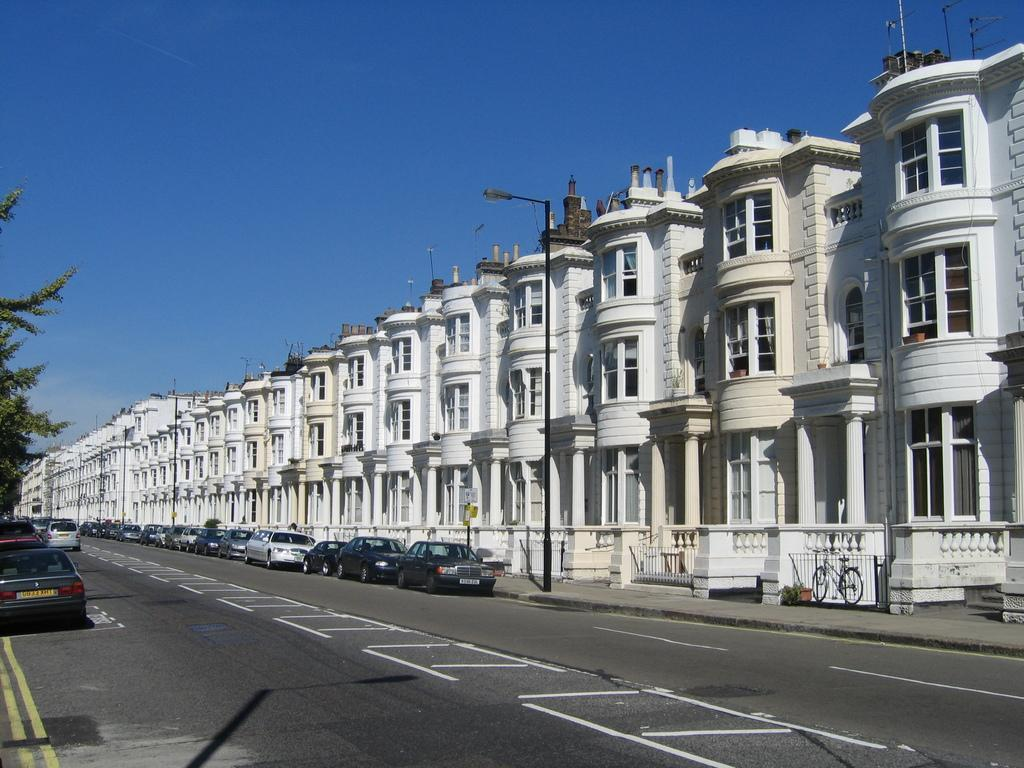What type of structures can be seen in the image? There are buildings in the image. What type of lighting is present in the image? There is a street lamp in the image. What architectural features can be seen on the buildings? There are windows visible in the image. What type of transportation is present in the image? There are vehicles in the image. What type of vegetation is present in the image? There is a tree in the image. What is visible in the background of the image? The sky is visible in the image. What type of glue is being used to hold the paper together in the image? There is no paper or glue present in the image; it features buildings, a street lamp, windows, vehicles, a tree, and the sky. What type of seashore can be seen in the image? There is no seashore present in the image; it features an urban setting with buildings, a street lamp, windows, vehicles, a tree, and the sky. 